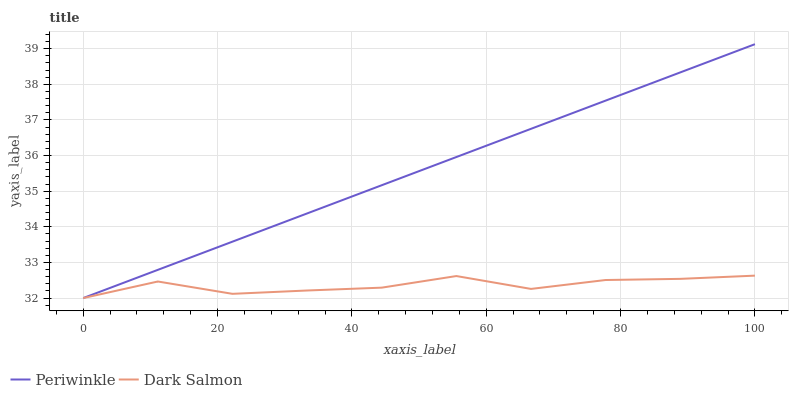Does Dark Salmon have the minimum area under the curve?
Answer yes or no. Yes. Does Periwinkle have the maximum area under the curve?
Answer yes or no. Yes. Does Dark Salmon have the maximum area under the curve?
Answer yes or no. No. Is Periwinkle the smoothest?
Answer yes or no. Yes. Is Dark Salmon the roughest?
Answer yes or no. Yes. Is Dark Salmon the smoothest?
Answer yes or no. No. Does Periwinkle have the lowest value?
Answer yes or no. Yes. Does Periwinkle have the highest value?
Answer yes or no. Yes. Does Dark Salmon have the highest value?
Answer yes or no. No. Does Dark Salmon intersect Periwinkle?
Answer yes or no. Yes. Is Dark Salmon less than Periwinkle?
Answer yes or no. No. Is Dark Salmon greater than Periwinkle?
Answer yes or no. No. 